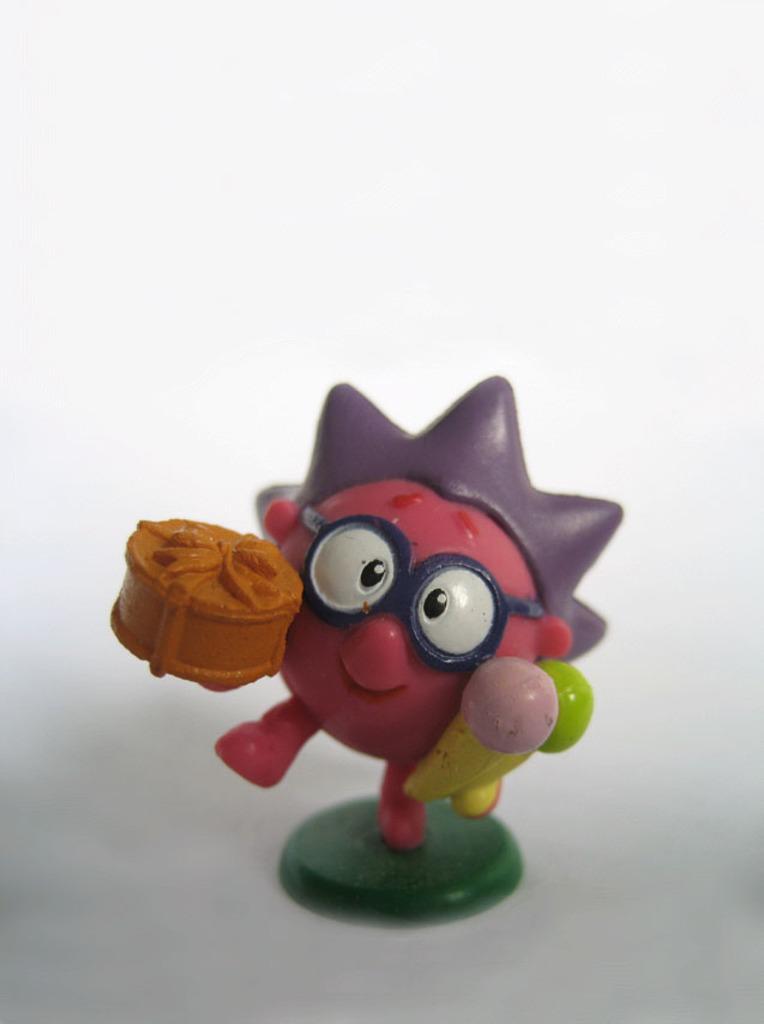Please provide a concise description of this image. In this image I can see a toy on a white surface. The background is in white color. 